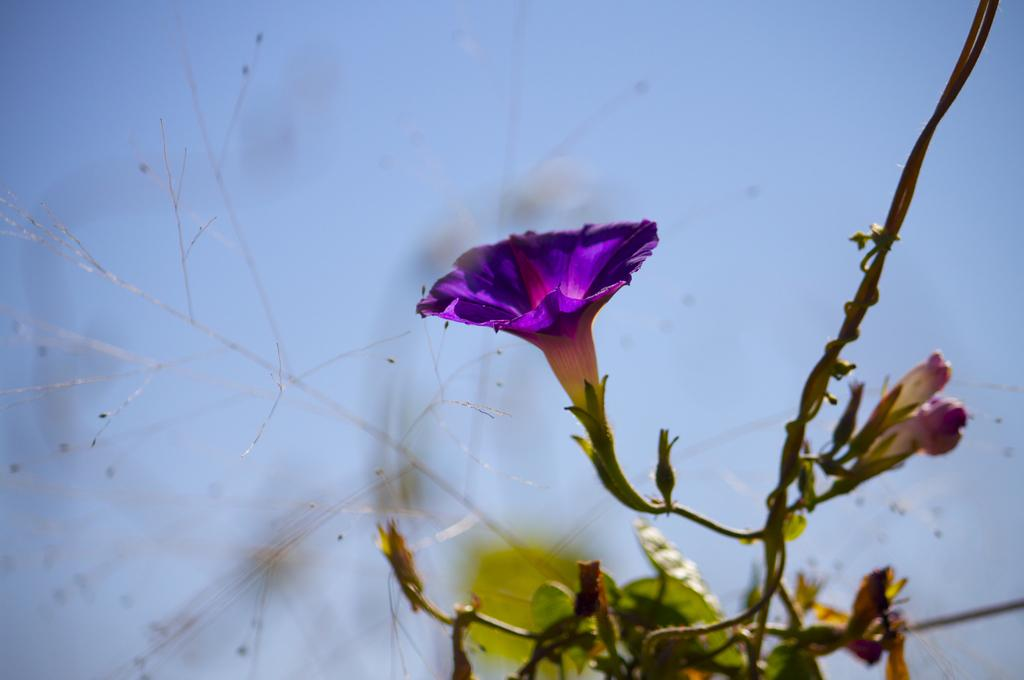What type of living organism can be seen in the picture? There is a plant in the picture. What stage of growth are the flowers on the plant in? The plant has flower buds and a violet flower. What can be seen in the background of the picture? There is a sky visible in the background of the picture. What type of farm animals can be seen grazing in the background of the image? There are no farm animals or any indication of a farm in the image; it features a plant with flowers and a sky in the background. 